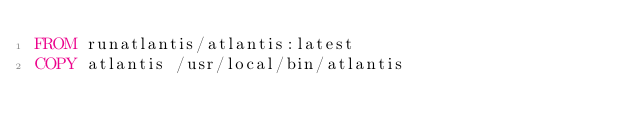<code> <loc_0><loc_0><loc_500><loc_500><_Dockerfile_>FROM runatlantis/atlantis:latest
COPY atlantis /usr/local/bin/atlantis
</code> 